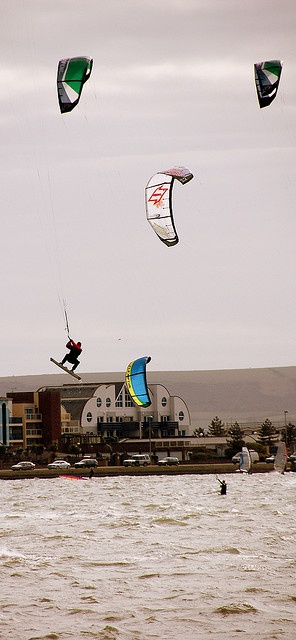Describe the objects in this image and their specific colors. I can see kite in lightgray, black, darkgray, and lightpink tones, kite in lightgray, black, darkgreen, and gray tones, kite in lightgray, black, lightblue, and teal tones, kite in lightgray, black, gray, and darkgray tones, and people in lightgray, black, maroon, and gray tones in this image. 